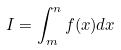Convert formula to latex. <formula><loc_0><loc_0><loc_500><loc_500>I = \int _ { m } ^ { n } f ( x ) d x</formula> 